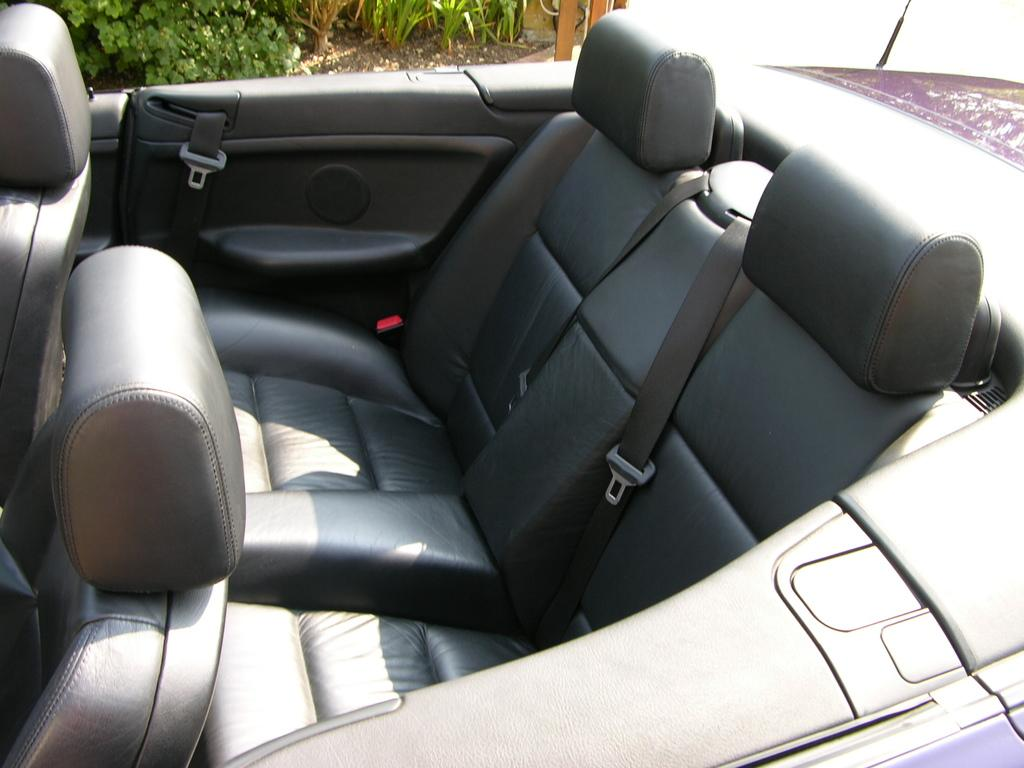What type of location is shown in the image? The image is an inside view of a car. What type of seating is available in the car? There are chairs in the car. What safety feature is present in the car? Seat belts are present in the car. What other items can be seen inside the car? There are other objects in the car. What can be seen at the top of the image? Plants and the ground are visible at the top of the image, along with other objects. What type of net is used to catch fish in the image? There is no net or fishing activity present in the image; it is an inside view of a car. What type of bait is used to attract fish in the image? There is no fishing activity or bait present in the image; it is an inside view of a car. 